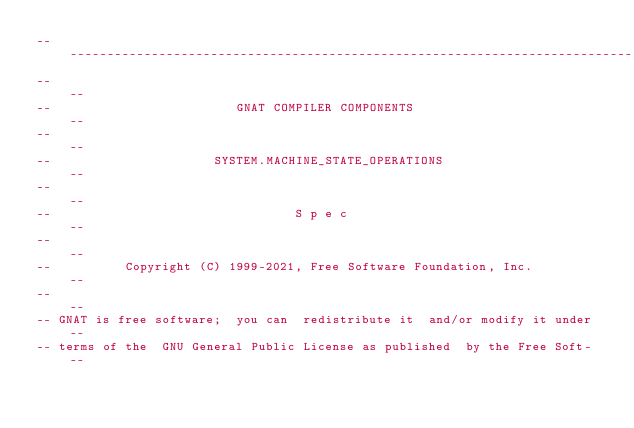<code> <loc_0><loc_0><loc_500><loc_500><_Ada_>------------------------------------------------------------------------------
--                                                                          --
--                         GNAT COMPILER COMPONENTS                         --
--                                                                          --
--                      SYSTEM.MACHINE_STATE_OPERATIONS                     --
--                                                                          --
--                                 S p e c                                  --
--                                                                          --
--          Copyright (C) 1999-2021, Free Software Foundation, Inc.         --
--                                                                          --
-- GNAT is free software;  you can  redistribute it  and/or modify it under --
-- terms of the  GNU General Public License as published  by the Free Soft- --</code> 